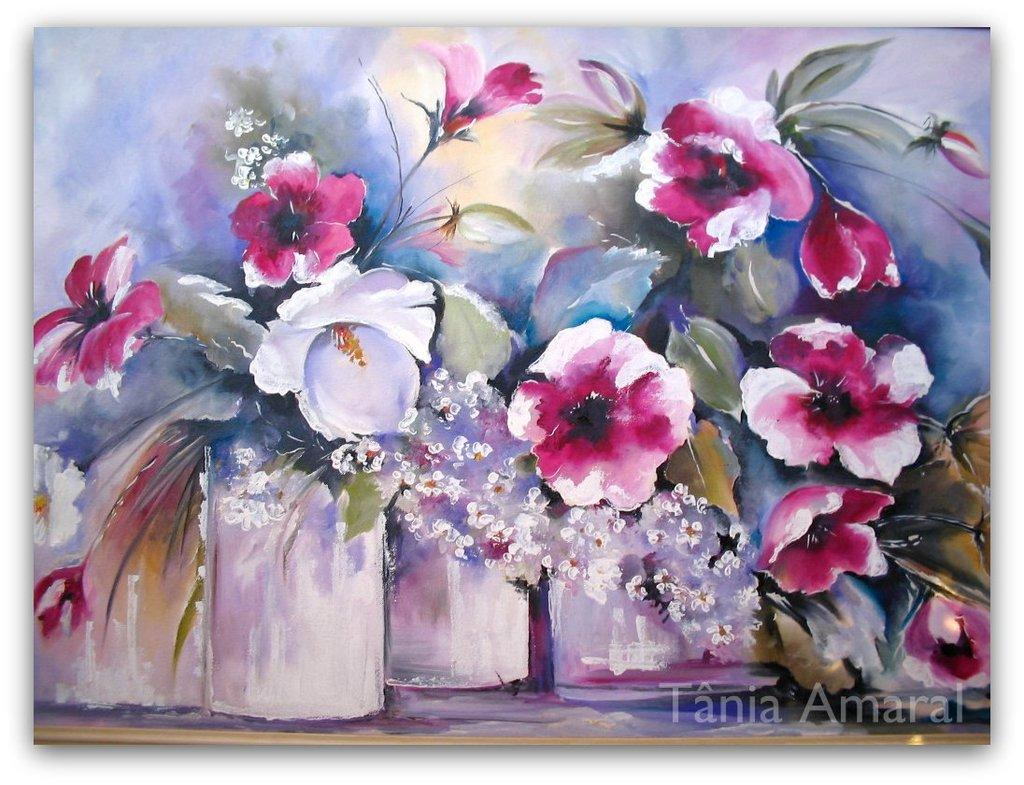What is the main subject of the image? The image contains a painting. What does the painting depict? The painting depicts flower pots. What colors are used for the flowers in the painting? The flowers in the painting are pink and white. What color are the leaves in the painting? The leaves in the painting are green. How many times did the artist slip while painting the flowers? There is no information about the artist or any slips during the painting process in the image. 